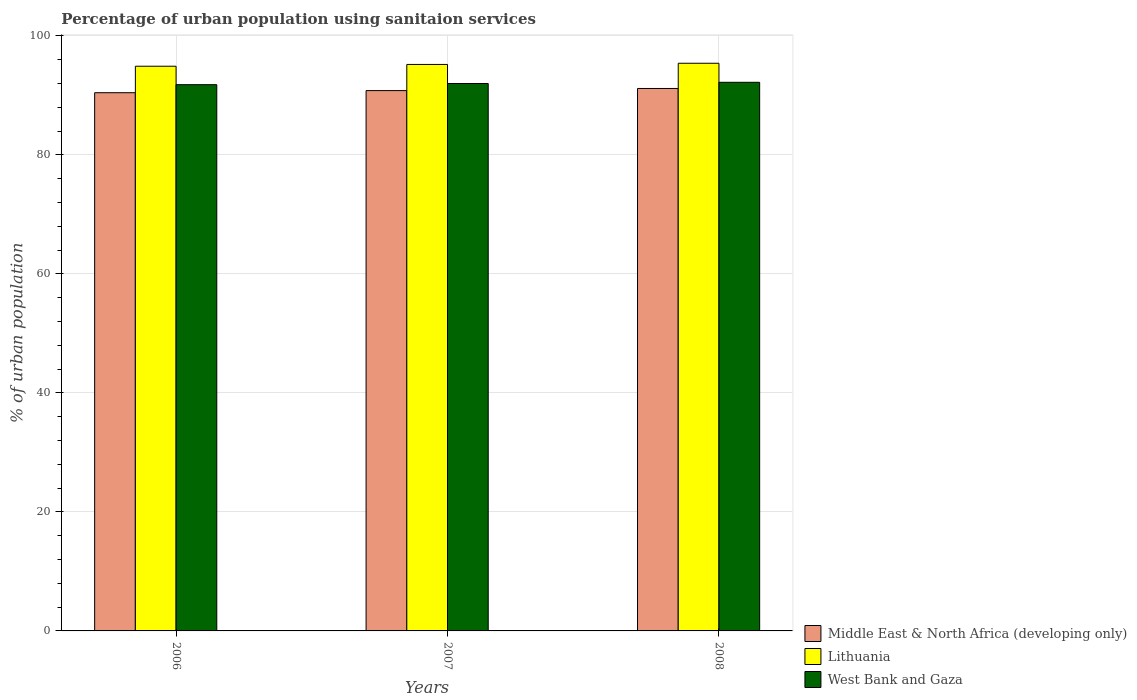How many groups of bars are there?
Your answer should be compact. 3. How many bars are there on the 3rd tick from the left?
Your answer should be compact. 3. What is the label of the 2nd group of bars from the left?
Offer a very short reply. 2007. In how many cases, is the number of bars for a given year not equal to the number of legend labels?
Provide a short and direct response. 0. What is the percentage of urban population using sanitaion services in West Bank and Gaza in 2008?
Provide a succinct answer. 92.2. Across all years, what is the maximum percentage of urban population using sanitaion services in Middle East & North Africa (developing only)?
Provide a short and direct response. 91.16. Across all years, what is the minimum percentage of urban population using sanitaion services in Lithuania?
Provide a short and direct response. 94.9. In which year was the percentage of urban population using sanitaion services in Lithuania maximum?
Offer a terse response. 2008. In which year was the percentage of urban population using sanitaion services in Lithuania minimum?
Make the answer very short. 2006. What is the total percentage of urban population using sanitaion services in Lithuania in the graph?
Ensure brevity in your answer.  285.5. What is the difference between the percentage of urban population using sanitaion services in Lithuania in 2006 and that in 2007?
Offer a very short reply. -0.3. What is the difference between the percentage of urban population using sanitaion services in Middle East & North Africa (developing only) in 2007 and the percentage of urban population using sanitaion services in Lithuania in 2006?
Provide a succinct answer. -4.09. What is the average percentage of urban population using sanitaion services in Lithuania per year?
Ensure brevity in your answer.  95.17. In the year 2006, what is the difference between the percentage of urban population using sanitaion services in West Bank and Gaza and percentage of urban population using sanitaion services in Lithuania?
Keep it short and to the point. -3.1. What is the ratio of the percentage of urban population using sanitaion services in Lithuania in 2007 to that in 2008?
Your answer should be compact. 1. What is the difference between the highest and the second highest percentage of urban population using sanitaion services in Lithuania?
Give a very brief answer. 0.2. What is the difference between the highest and the lowest percentage of urban population using sanitaion services in Lithuania?
Offer a terse response. 0.5. In how many years, is the percentage of urban population using sanitaion services in Lithuania greater than the average percentage of urban population using sanitaion services in Lithuania taken over all years?
Keep it short and to the point. 2. Is the sum of the percentage of urban population using sanitaion services in Middle East & North Africa (developing only) in 2007 and 2008 greater than the maximum percentage of urban population using sanitaion services in West Bank and Gaza across all years?
Make the answer very short. Yes. What does the 3rd bar from the left in 2006 represents?
Offer a very short reply. West Bank and Gaza. What does the 2nd bar from the right in 2007 represents?
Keep it short and to the point. Lithuania. How many years are there in the graph?
Your answer should be very brief. 3. What is the difference between two consecutive major ticks on the Y-axis?
Ensure brevity in your answer.  20. Are the values on the major ticks of Y-axis written in scientific E-notation?
Ensure brevity in your answer.  No. Does the graph contain any zero values?
Give a very brief answer. No. Does the graph contain grids?
Your response must be concise. Yes. How are the legend labels stacked?
Make the answer very short. Vertical. What is the title of the graph?
Your response must be concise. Percentage of urban population using sanitaion services. Does "Denmark" appear as one of the legend labels in the graph?
Ensure brevity in your answer.  No. What is the label or title of the Y-axis?
Offer a very short reply. % of urban population. What is the % of urban population of Middle East & North Africa (developing only) in 2006?
Provide a short and direct response. 90.45. What is the % of urban population in Lithuania in 2006?
Your answer should be very brief. 94.9. What is the % of urban population in West Bank and Gaza in 2006?
Give a very brief answer. 91.8. What is the % of urban population in Middle East & North Africa (developing only) in 2007?
Your answer should be very brief. 90.81. What is the % of urban population of Lithuania in 2007?
Provide a short and direct response. 95.2. What is the % of urban population in West Bank and Gaza in 2007?
Provide a short and direct response. 92. What is the % of urban population of Middle East & North Africa (developing only) in 2008?
Provide a succinct answer. 91.16. What is the % of urban population in Lithuania in 2008?
Keep it short and to the point. 95.4. What is the % of urban population in West Bank and Gaza in 2008?
Provide a short and direct response. 92.2. Across all years, what is the maximum % of urban population in Middle East & North Africa (developing only)?
Keep it short and to the point. 91.16. Across all years, what is the maximum % of urban population in Lithuania?
Offer a terse response. 95.4. Across all years, what is the maximum % of urban population of West Bank and Gaza?
Your answer should be compact. 92.2. Across all years, what is the minimum % of urban population of Middle East & North Africa (developing only)?
Offer a very short reply. 90.45. Across all years, what is the minimum % of urban population of Lithuania?
Make the answer very short. 94.9. Across all years, what is the minimum % of urban population in West Bank and Gaza?
Give a very brief answer. 91.8. What is the total % of urban population of Middle East & North Africa (developing only) in the graph?
Give a very brief answer. 272.42. What is the total % of urban population in Lithuania in the graph?
Make the answer very short. 285.5. What is the total % of urban population in West Bank and Gaza in the graph?
Provide a short and direct response. 276. What is the difference between the % of urban population of Middle East & North Africa (developing only) in 2006 and that in 2007?
Your response must be concise. -0.36. What is the difference between the % of urban population of Lithuania in 2006 and that in 2007?
Give a very brief answer. -0.3. What is the difference between the % of urban population in Middle East & North Africa (developing only) in 2006 and that in 2008?
Provide a short and direct response. -0.71. What is the difference between the % of urban population of Lithuania in 2006 and that in 2008?
Offer a very short reply. -0.5. What is the difference between the % of urban population in West Bank and Gaza in 2006 and that in 2008?
Offer a terse response. -0.4. What is the difference between the % of urban population of Middle East & North Africa (developing only) in 2007 and that in 2008?
Provide a short and direct response. -0.36. What is the difference between the % of urban population in Lithuania in 2007 and that in 2008?
Your answer should be very brief. -0.2. What is the difference between the % of urban population in West Bank and Gaza in 2007 and that in 2008?
Ensure brevity in your answer.  -0.2. What is the difference between the % of urban population in Middle East & North Africa (developing only) in 2006 and the % of urban population in Lithuania in 2007?
Offer a terse response. -4.75. What is the difference between the % of urban population of Middle East & North Africa (developing only) in 2006 and the % of urban population of West Bank and Gaza in 2007?
Provide a short and direct response. -1.55. What is the difference between the % of urban population in Lithuania in 2006 and the % of urban population in West Bank and Gaza in 2007?
Provide a short and direct response. 2.9. What is the difference between the % of urban population of Middle East & North Africa (developing only) in 2006 and the % of urban population of Lithuania in 2008?
Ensure brevity in your answer.  -4.95. What is the difference between the % of urban population of Middle East & North Africa (developing only) in 2006 and the % of urban population of West Bank and Gaza in 2008?
Keep it short and to the point. -1.75. What is the difference between the % of urban population of Middle East & North Africa (developing only) in 2007 and the % of urban population of Lithuania in 2008?
Your response must be concise. -4.59. What is the difference between the % of urban population of Middle East & North Africa (developing only) in 2007 and the % of urban population of West Bank and Gaza in 2008?
Give a very brief answer. -1.39. What is the average % of urban population in Middle East & North Africa (developing only) per year?
Offer a terse response. 90.81. What is the average % of urban population in Lithuania per year?
Your response must be concise. 95.17. What is the average % of urban population of West Bank and Gaza per year?
Offer a very short reply. 92. In the year 2006, what is the difference between the % of urban population in Middle East & North Africa (developing only) and % of urban population in Lithuania?
Your answer should be very brief. -4.45. In the year 2006, what is the difference between the % of urban population in Middle East & North Africa (developing only) and % of urban population in West Bank and Gaza?
Provide a short and direct response. -1.35. In the year 2006, what is the difference between the % of urban population in Lithuania and % of urban population in West Bank and Gaza?
Offer a terse response. 3.1. In the year 2007, what is the difference between the % of urban population of Middle East & North Africa (developing only) and % of urban population of Lithuania?
Your answer should be compact. -4.39. In the year 2007, what is the difference between the % of urban population in Middle East & North Africa (developing only) and % of urban population in West Bank and Gaza?
Offer a very short reply. -1.19. In the year 2007, what is the difference between the % of urban population of Lithuania and % of urban population of West Bank and Gaza?
Offer a terse response. 3.2. In the year 2008, what is the difference between the % of urban population of Middle East & North Africa (developing only) and % of urban population of Lithuania?
Your answer should be very brief. -4.24. In the year 2008, what is the difference between the % of urban population of Middle East & North Africa (developing only) and % of urban population of West Bank and Gaza?
Provide a short and direct response. -1.04. In the year 2008, what is the difference between the % of urban population of Lithuania and % of urban population of West Bank and Gaza?
Give a very brief answer. 3.2. What is the ratio of the % of urban population in Lithuania in 2006 to that in 2007?
Your response must be concise. 1. What is the ratio of the % of urban population in West Bank and Gaza in 2006 to that in 2007?
Offer a very short reply. 1. What is the ratio of the % of urban population in Middle East & North Africa (developing only) in 2007 to that in 2008?
Give a very brief answer. 1. What is the ratio of the % of urban population in West Bank and Gaza in 2007 to that in 2008?
Your answer should be compact. 1. What is the difference between the highest and the second highest % of urban population in Middle East & North Africa (developing only)?
Offer a very short reply. 0.36. What is the difference between the highest and the second highest % of urban population in Lithuania?
Offer a very short reply. 0.2. What is the difference between the highest and the second highest % of urban population of West Bank and Gaza?
Offer a terse response. 0.2. What is the difference between the highest and the lowest % of urban population in Middle East & North Africa (developing only)?
Make the answer very short. 0.71. 